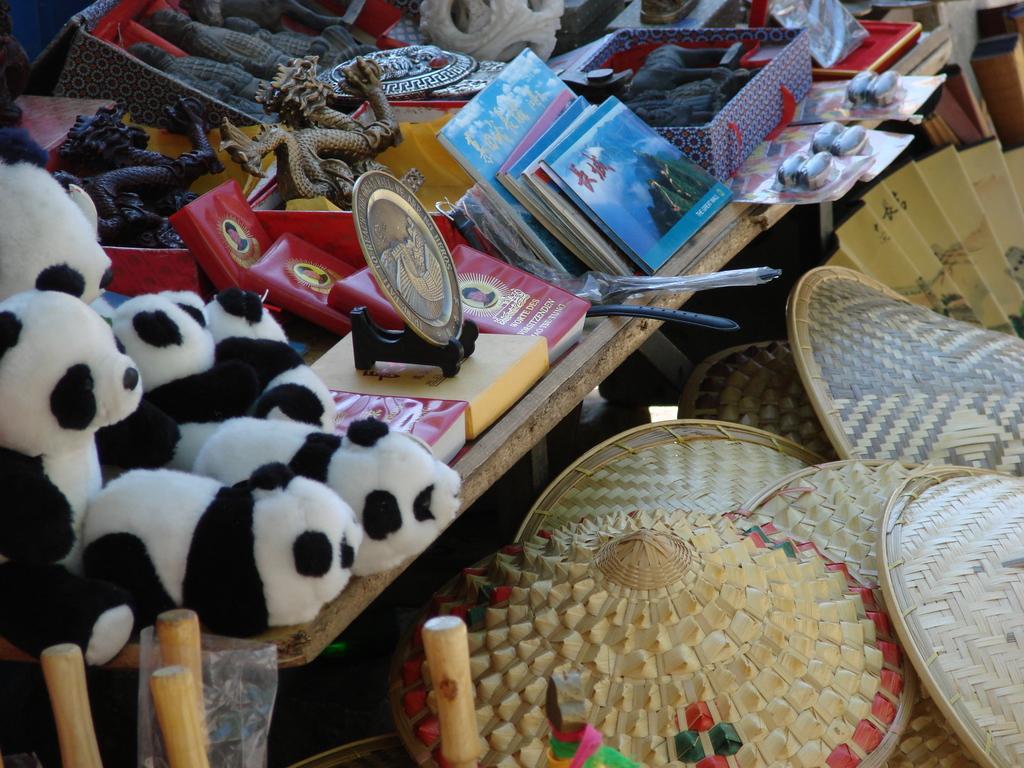How would you summarize this image in a sentence or two? In this image I can see a wooden table and on the wooden table I can see few panda toys, few books, the shield, few dragon statues, a box with few objects in them and few other objects. To the right bottom of the image I can see wooden hats. 